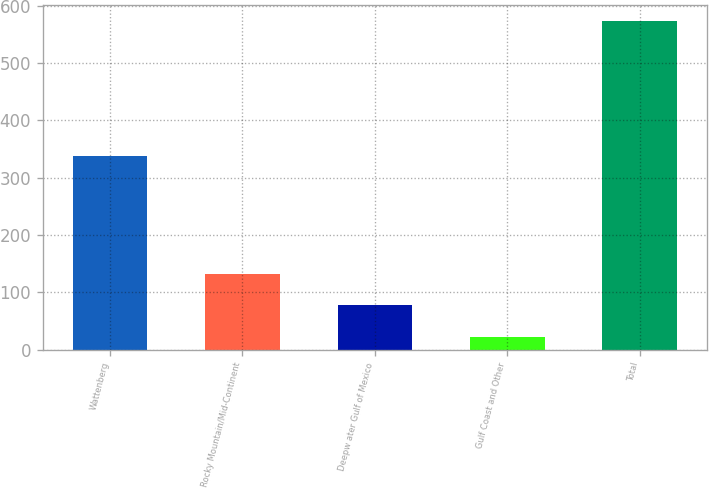Convert chart. <chart><loc_0><loc_0><loc_500><loc_500><bar_chart><fcel>Wattenberg<fcel>Rocky Mountain/Mid-Continent<fcel>Deepw ater Gulf of Mexico<fcel>Gulf Coast and Other<fcel>Total<nl><fcel>337<fcel>132.2<fcel>77.1<fcel>22<fcel>573<nl></chart> 